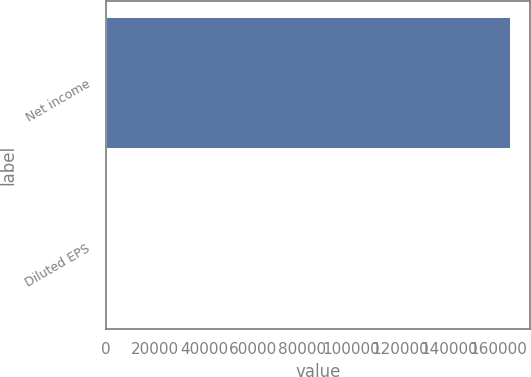Convert chart to OTSL. <chart><loc_0><loc_0><loc_500><loc_500><bar_chart><fcel>Net income<fcel>Diluted EPS<nl><fcel>164786<fcel>0.56<nl></chart> 